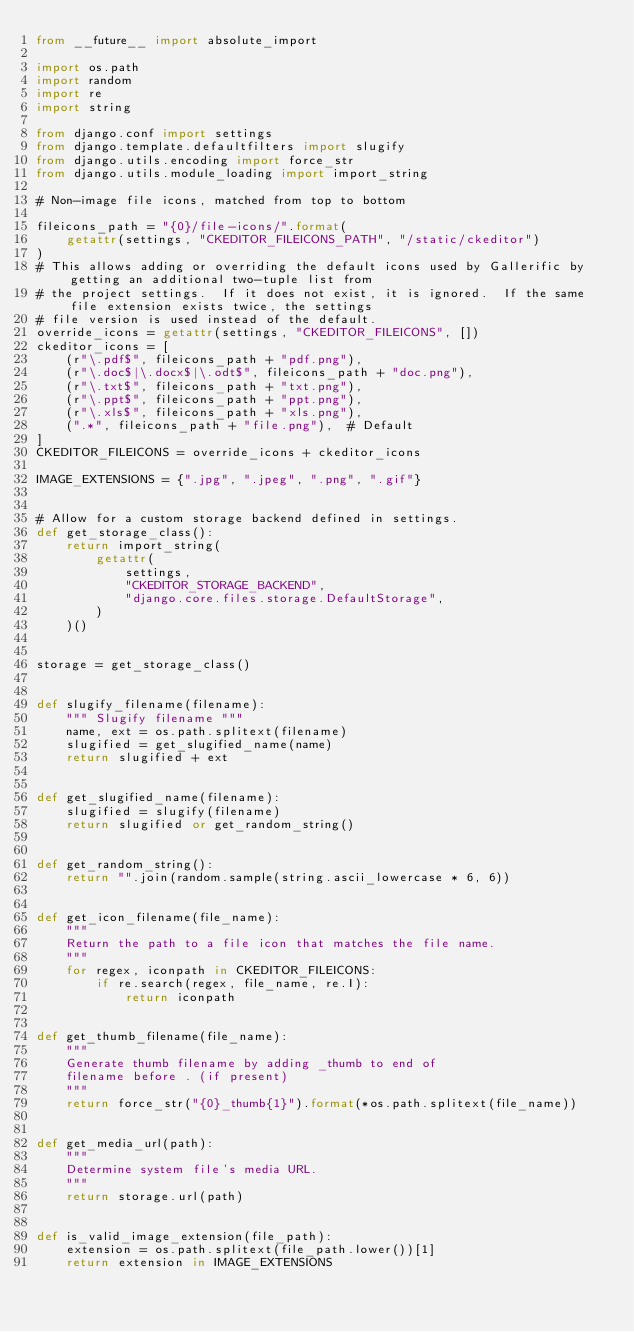Convert code to text. <code><loc_0><loc_0><loc_500><loc_500><_Python_>from __future__ import absolute_import

import os.path
import random
import re
import string

from django.conf import settings
from django.template.defaultfilters import slugify
from django.utils.encoding import force_str
from django.utils.module_loading import import_string

# Non-image file icons, matched from top to bottom

fileicons_path = "{0}/file-icons/".format(
    getattr(settings, "CKEDITOR_FILEICONS_PATH", "/static/ckeditor")
)
# This allows adding or overriding the default icons used by Gallerific by getting an additional two-tuple list from
# the project settings.  If it does not exist, it is ignored.  If the same file extension exists twice, the settings
# file version is used instead of the default.
override_icons = getattr(settings, "CKEDITOR_FILEICONS", [])
ckeditor_icons = [
    (r"\.pdf$", fileicons_path + "pdf.png"),
    (r"\.doc$|\.docx$|\.odt$", fileicons_path + "doc.png"),
    (r"\.txt$", fileicons_path + "txt.png"),
    (r"\.ppt$", fileicons_path + "ppt.png"),
    (r"\.xls$", fileicons_path + "xls.png"),
    (".*", fileicons_path + "file.png"),  # Default
]
CKEDITOR_FILEICONS = override_icons + ckeditor_icons

IMAGE_EXTENSIONS = {".jpg", ".jpeg", ".png", ".gif"}


# Allow for a custom storage backend defined in settings.
def get_storage_class():
    return import_string(
        getattr(
            settings,
            "CKEDITOR_STORAGE_BACKEND",
            "django.core.files.storage.DefaultStorage",
        )
    )()


storage = get_storage_class()


def slugify_filename(filename):
    """ Slugify filename """
    name, ext = os.path.splitext(filename)
    slugified = get_slugified_name(name)
    return slugified + ext


def get_slugified_name(filename):
    slugified = slugify(filename)
    return slugified or get_random_string()


def get_random_string():
    return "".join(random.sample(string.ascii_lowercase * 6, 6))


def get_icon_filename(file_name):
    """
    Return the path to a file icon that matches the file name.
    """
    for regex, iconpath in CKEDITOR_FILEICONS:
        if re.search(regex, file_name, re.I):
            return iconpath


def get_thumb_filename(file_name):
    """
    Generate thumb filename by adding _thumb to end of
    filename before . (if present)
    """
    return force_str("{0}_thumb{1}").format(*os.path.splitext(file_name))


def get_media_url(path):
    """
    Determine system file's media URL.
    """
    return storage.url(path)


def is_valid_image_extension(file_path):
    extension = os.path.splitext(file_path.lower())[1]
    return extension in IMAGE_EXTENSIONS
</code> 